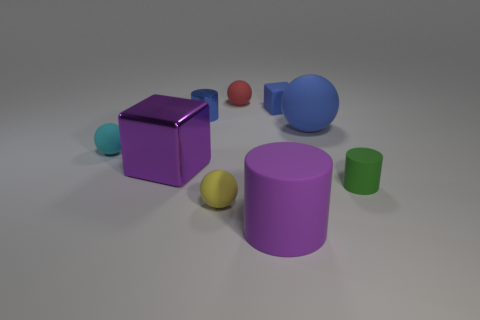Are there any patterns or consistencies in the arrangement of the objects? The objects are arranged loosely from left to right, with varied spacing between them. There's a subtle pattern where objects are paired by proximity: the small teal sphere is near the purple cube, the yellow sphere is close to the purple cylinder, and the green cylinder is positioned near the blue cylinder and red ball. However, there is no strict grid or symmetrical pattern. 